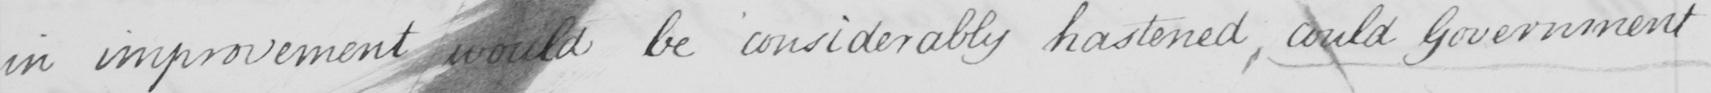What text is written in this handwritten line? in improvement would be considerable hastened, could Government 